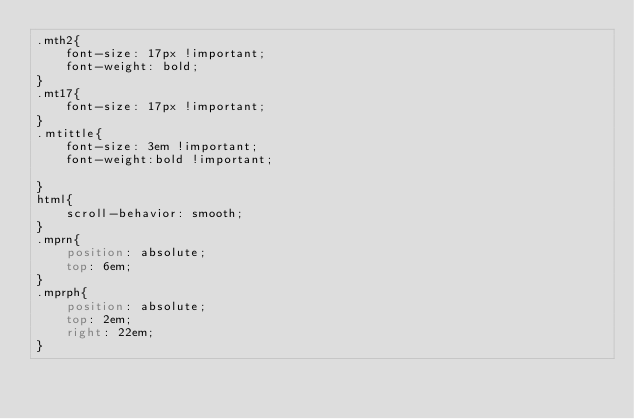Convert code to text. <code><loc_0><loc_0><loc_500><loc_500><_CSS_>.mth2{
    font-size: 17px !important;
    font-weight: bold;
}
.mt17{
    font-size: 17px !important;
}
.mtittle{
    font-size: 3em !important;
    font-weight:bold !important;

}
html{
    scroll-behavior: smooth;
}
.mprn{
    position: absolute;
    top: 6em;
}
.mprph{
    position: absolute;
    top: 2em;
    right: 22em;
}</code> 